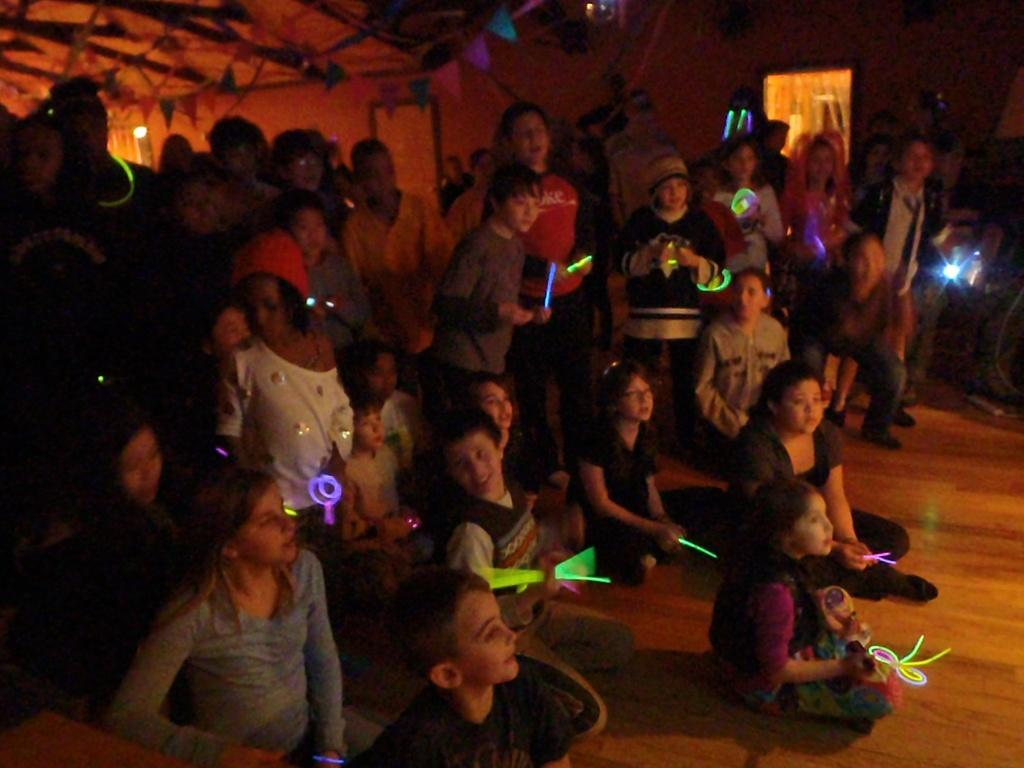How many people are in the image? There is a group of people in the image. What are the people doing in the image? The people are on the floor and holding an object. What can be seen at the top of the image? There are flags at the top of the image. What features can be found on the wall in the image? There is a mirror and a light on the wall in the image. What type of cord is being used by the bird in the image? There is no bird present in the image, and therefore no cord being used by a bird. How many worms can be seen crawling on the wall in the image? There are no worms present in the image; the wall features a mirror and a light. 